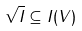<formula> <loc_0><loc_0><loc_500><loc_500>\sqrt { I } \subseteq I ( V )</formula> 